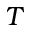<formula> <loc_0><loc_0><loc_500><loc_500>T</formula> 